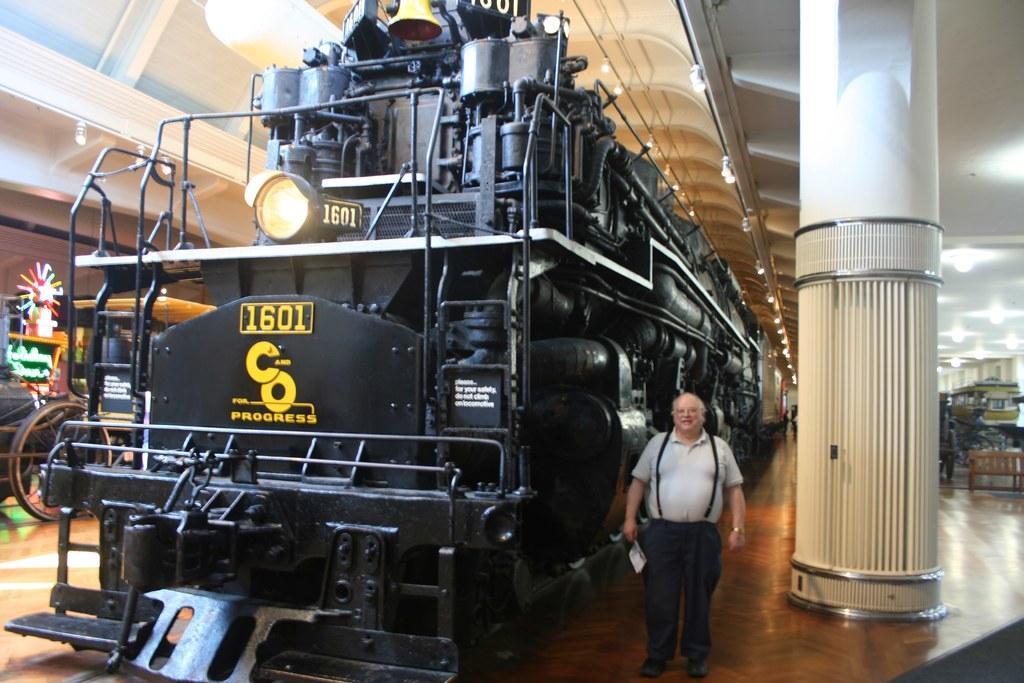Can you describe this image briefly? In this image I can see the machine which is in black color. To the side I can see the person standing and wearing the white color dress. I can also the pillar to the right. To the left I can see the cart. I can also see the lights in the top. To the right I cans the bench which is in brown color. 